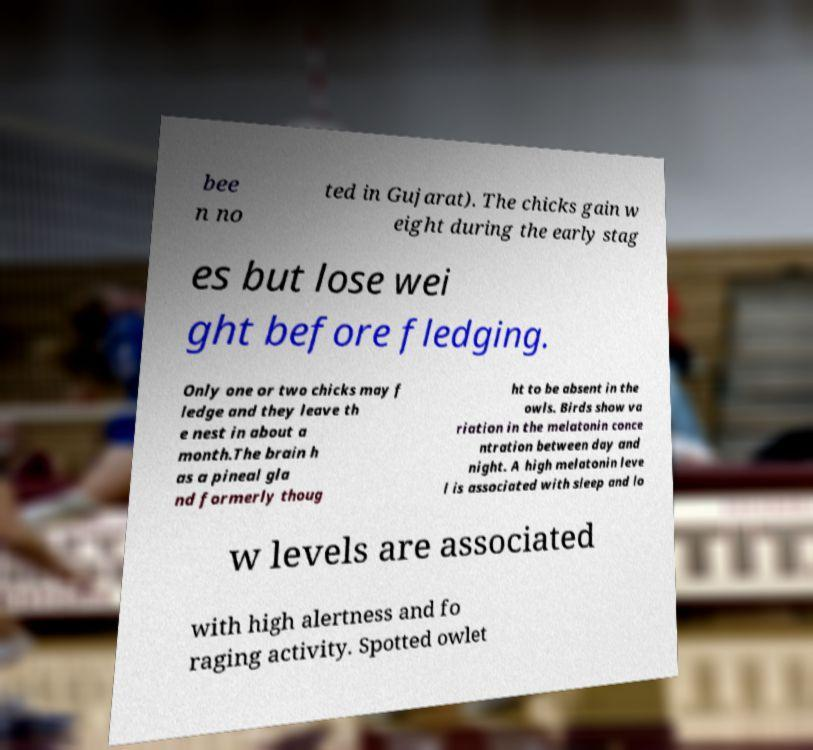Please identify and transcribe the text found in this image. bee n no ted in Gujarat). The chicks gain w eight during the early stag es but lose wei ght before fledging. Only one or two chicks may f ledge and they leave th e nest in about a month.The brain h as a pineal gla nd formerly thoug ht to be absent in the owls. Birds show va riation in the melatonin conce ntration between day and night. A high melatonin leve l is associated with sleep and lo w levels are associated with high alertness and fo raging activity. Spotted owlet 